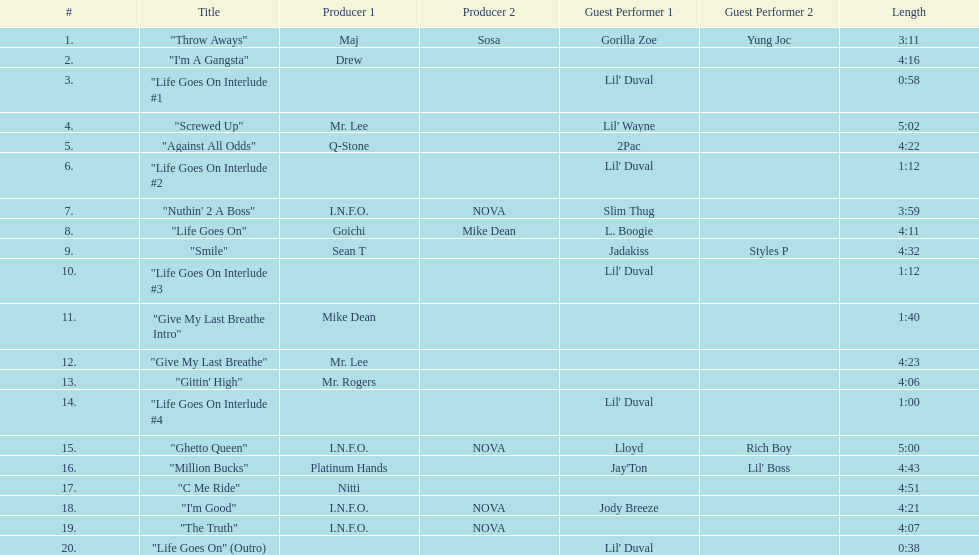What is the longest track on the album? "Screwed Up". 